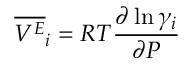Convert formula to latex. <formula><loc_0><loc_0><loc_500><loc_500>{ \overline { { V ^ { E } } } } _ { i } = R T { \frac { \partial \ln \gamma _ { i } } { \partial P } }</formula> 